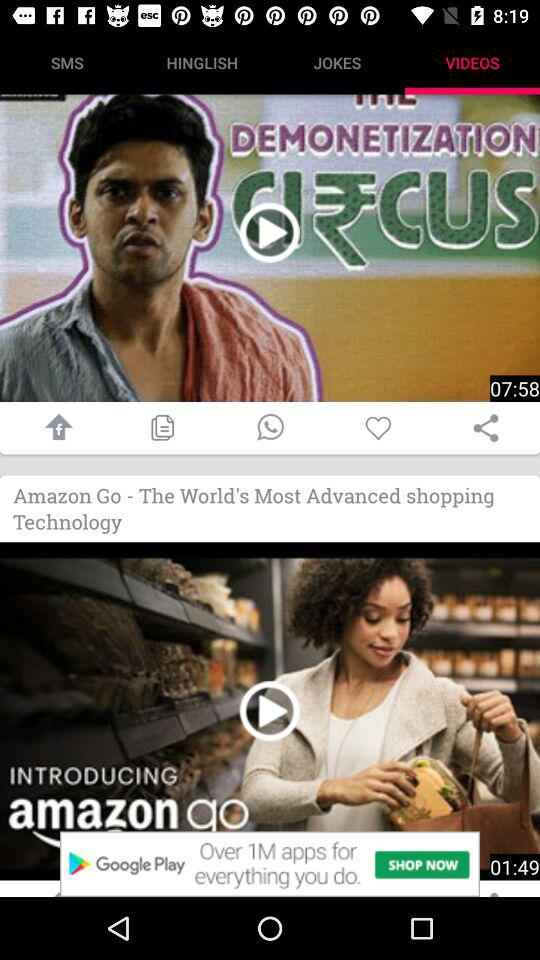Which tab is selected? The selected tab is "VIDEOS". 